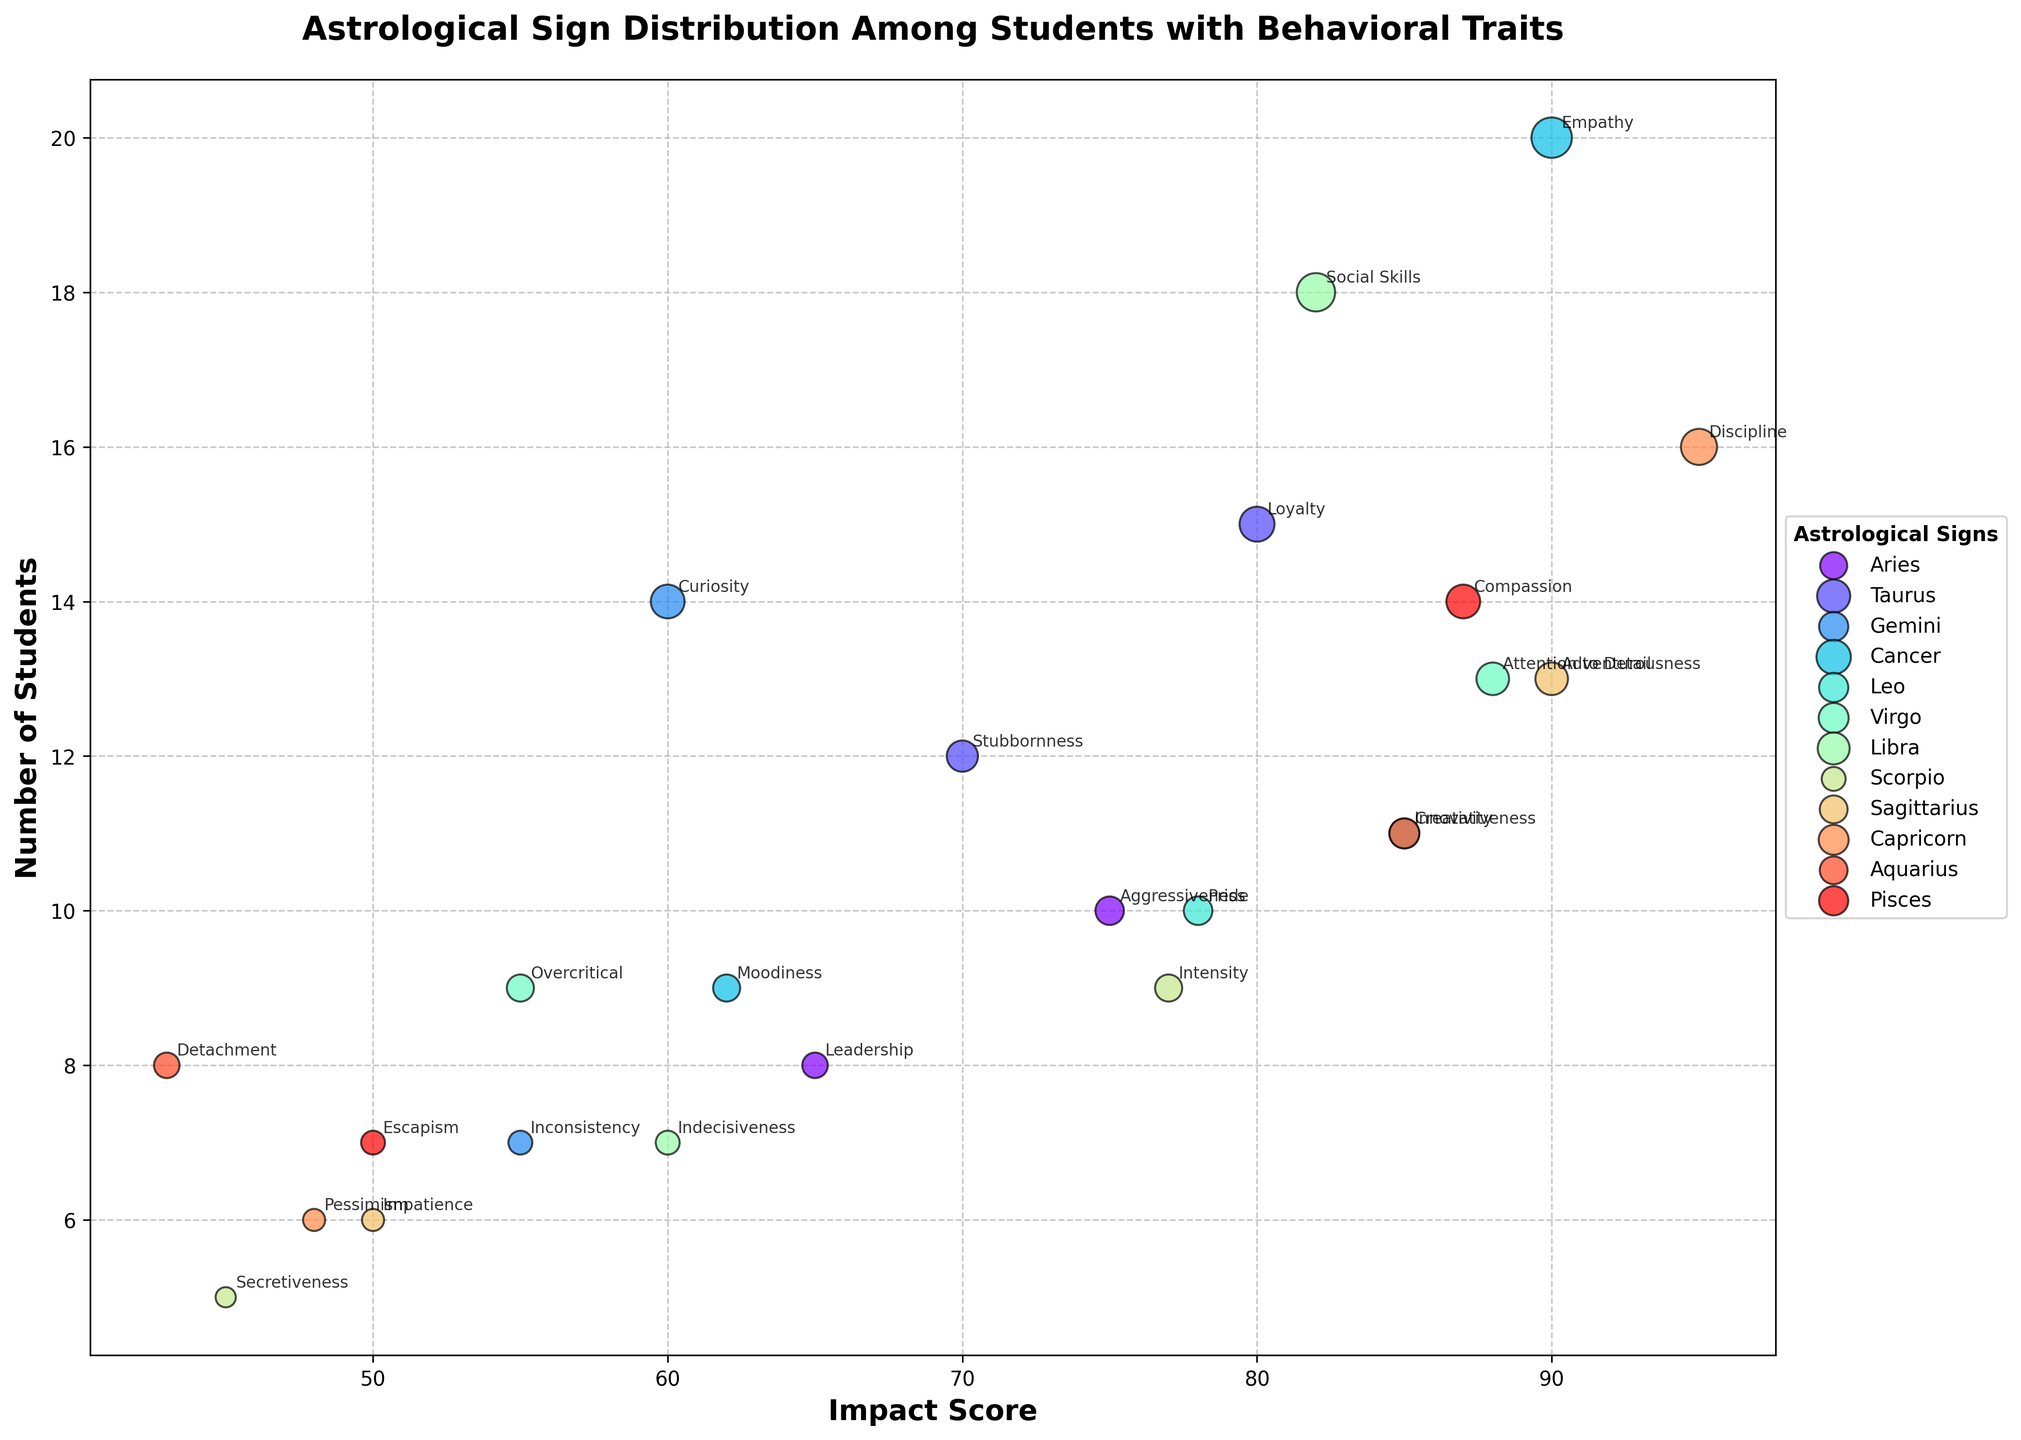What is the behavioral trait with the highest impact score among students? The highest impact score can be found by locating the marker that is farthest to the right along the x-axis. By examining the figure, the trait associated with Capricorn, "Discipline," has the highest impact score of 95.
Answer: Discipline Which astrological sign has the most students associated with a single trait? Look for the bubble with the largest size, which represents the highest number of students. The largest bubble is related to Cancer with the trait "Empathy," which has 20 students.
Answer: Cancer Which behavioral trait associated with Scorpio has a higher impact score? To determine this, we examine the vertical positioning of the bubbles labeled with Scorpio traits and compare their x-axis values. "Intensity" has an impact score of 77, which is higher than "Secretiveness" with an impact score of 45.
Answer: Intensity Which astrological sign has the least impactful trait and how many students does it affect? Identify the smallest impact score by looking for the leftmost bubble. "Detachment" associated with Aquarius has the lowest impact score of 43, and 8 students are associated with this trait.
Answer: Aquarius, and 8 students What is the average impact score for the behavioral traits associated with Taurus? Calculate the average by adding the impact scores for "Stubbornness" (70) and "Loyalty" (80), then divide by the number of traits. The sum is 70 + 80 = 150, and the average is 150 / 2 = 75.
Answer: 75 Which astrological sign has traits with both high impact and significant student numbers? Look for signs that have bubbles positioned high on the y-axis and far to the right on the x-axis. Capricorn's trait "Discipline" stands out with an impact score of 95 and 16 students.
Answer: Capricorn What is the sum of all students associated with the traits of Leo? Add the number of students associated with "Creativity" (11) and "Pride" (10). The sum is 11 + 10 = 21.
Answer: 21 Which trait has more students associated with it: Gemini's "Inconsistency" or Virgo's "Overcritical"? Compare the bubbles for these traits by looking at their y-axis position. "Inconsistency" has 7 students, while "Overcritical" also has 9 students.
Answer: Overcritical How many behavioral traits have an impact score above 80, and which signs do they belong to? Identify the bubbles positioned to the right of the 80 mark on the x-axis. The traits are "Empathy" (Cancer), "Creativity" (Leo), "Discipline" (Capricorn), "Adventurousness" (Sagittarius), "Attention to Detail" (Virgo), "Loyalty" (Taurus), and "Social Skills" (Libra).
Answer: 6 Which behavioral trait associated with Sagittarius has a lower impact score and by how much? Compare the x-axis values of the bubbles labeled with Sagittarius traits. "Adventurousness" has an impact score of 90, and "Impatience" has an impact score of 50. The difference is 90 - 50 = 40.
Answer: Impatience, by 40 